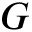<formula> <loc_0><loc_0><loc_500><loc_500>G</formula> 